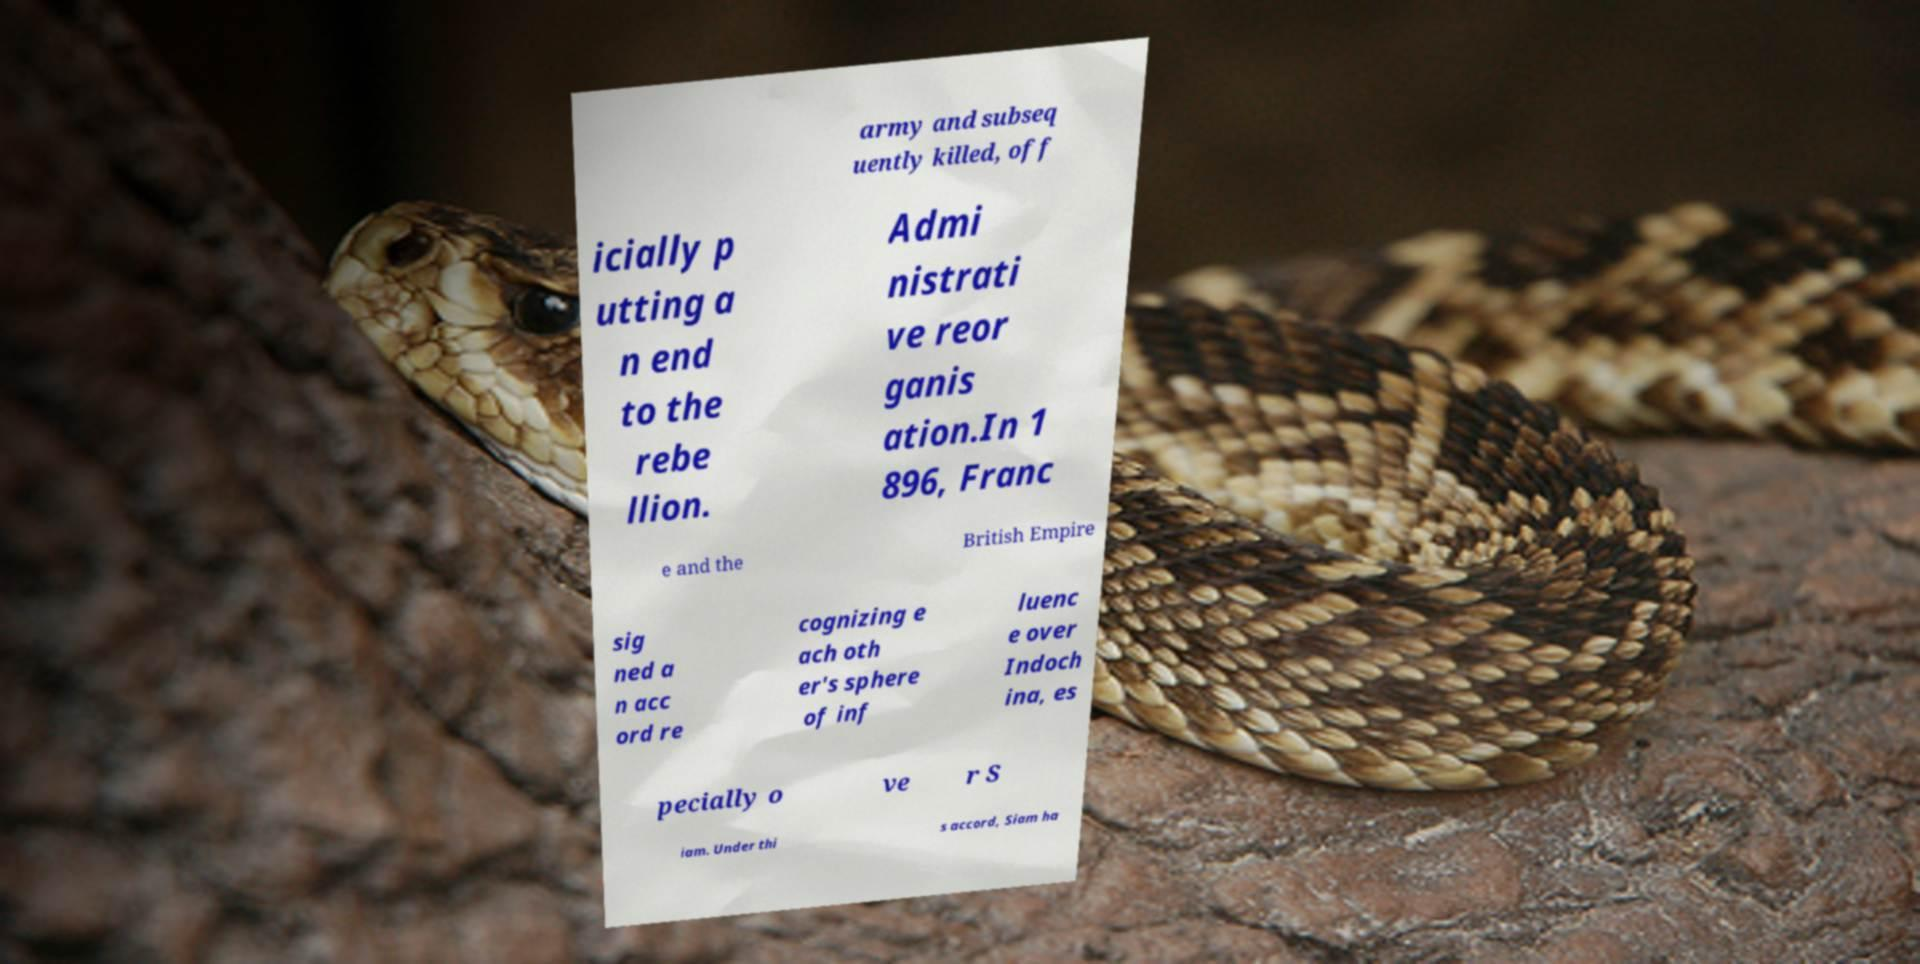Please read and relay the text visible in this image. What does it say? army and subseq uently killed, off icially p utting a n end to the rebe llion. Admi nistrati ve reor ganis ation.In 1 896, Franc e and the British Empire sig ned a n acc ord re cognizing e ach oth er's sphere of inf luenc e over Indoch ina, es pecially o ve r S iam. Under thi s accord, Siam ha 